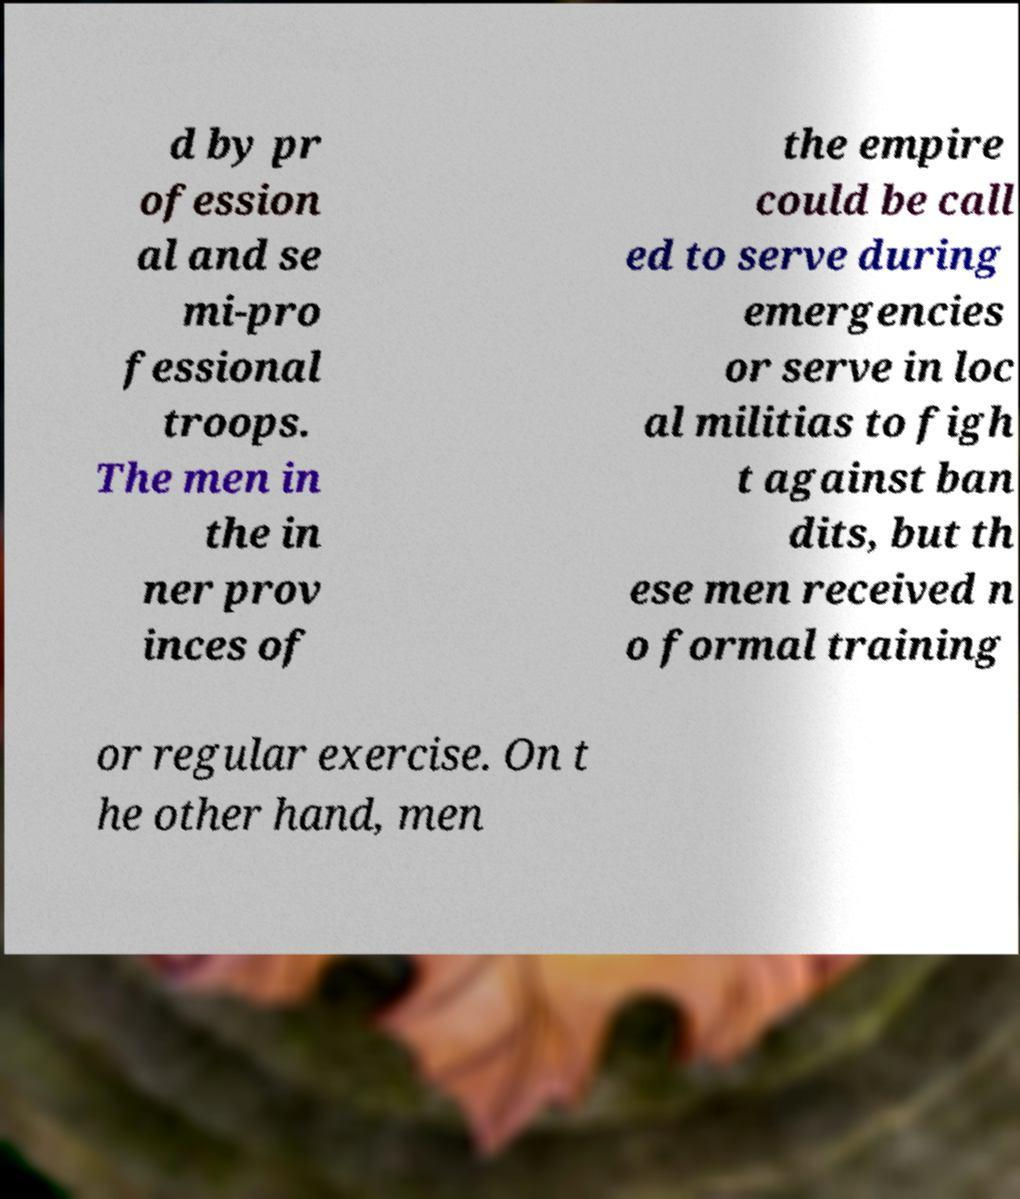What messages or text are displayed in this image? I need them in a readable, typed format. d by pr ofession al and se mi-pro fessional troops. The men in the in ner prov inces of the empire could be call ed to serve during emergencies or serve in loc al militias to figh t against ban dits, but th ese men received n o formal training or regular exercise. On t he other hand, men 